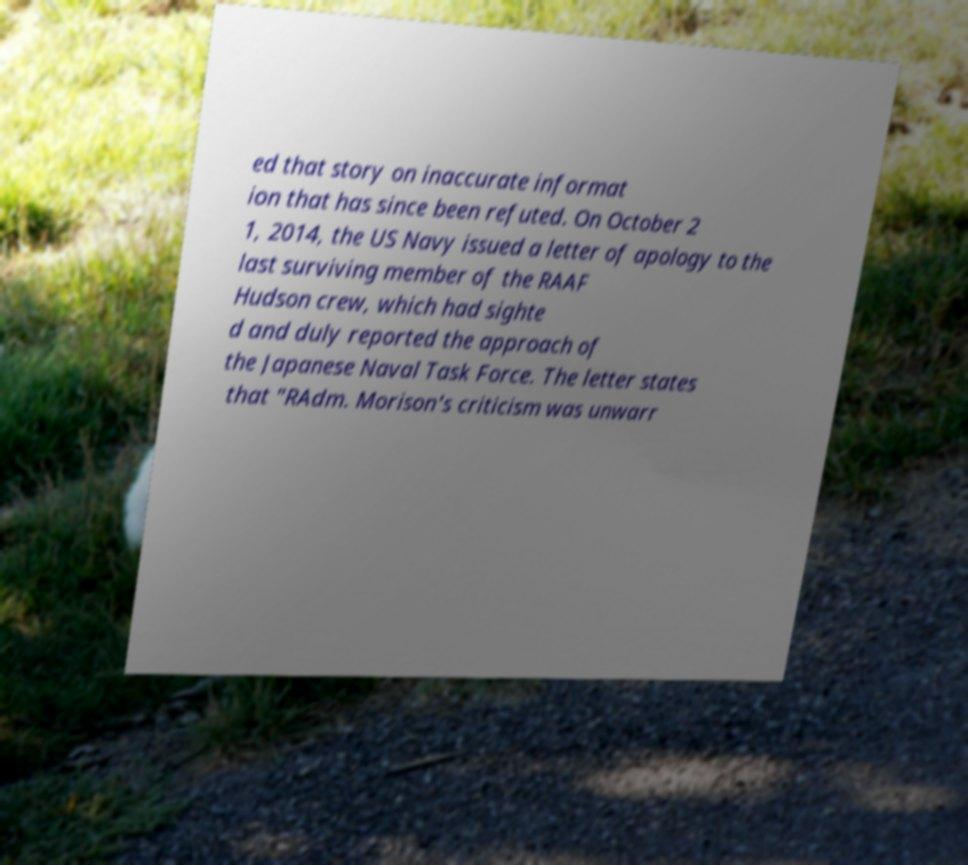Please identify and transcribe the text found in this image. ed that story on inaccurate informat ion that has since been refuted. On October 2 1, 2014, the US Navy issued a letter of apology to the last surviving member of the RAAF Hudson crew, which had sighte d and duly reported the approach of the Japanese Naval Task Force. The letter states that "RAdm. Morison's criticism was unwarr 